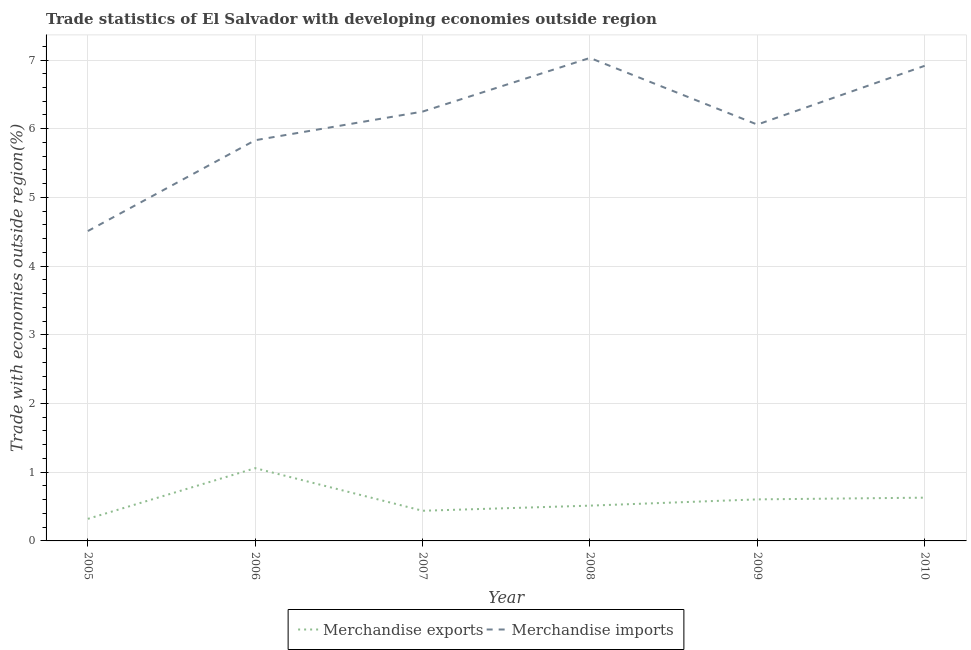Does the line corresponding to merchandise exports intersect with the line corresponding to merchandise imports?
Offer a terse response. No. Is the number of lines equal to the number of legend labels?
Keep it short and to the point. Yes. What is the merchandise exports in 2008?
Provide a succinct answer. 0.51. Across all years, what is the maximum merchandise exports?
Give a very brief answer. 1.06. Across all years, what is the minimum merchandise exports?
Your answer should be compact. 0.32. In which year was the merchandise imports maximum?
Your response must be concise. 2008. In which year was the merchandise imports minimum?
Your response must be concise. 2005. What is the total merchandise imports in the graph?
Make the answer very short. 36.6. What is the difference between the merchandise imports in 2008 and that in 2010?
Keep it short and to the point. 0.11. What is the difference between the merchandise imports in 2010 and the merchandise exports in 2008?
Provide a short and direct response. 6.4. What is the average merchandise imports per year?
Offer a very short reply. 6.1. In the year 2010, what is the difference between the merchandise imports and merchandise exports?
Provide a succinct answer. 6.29. In how many years, is the merchandise imports greater than 1.2 %?
Your answer should be compact. 6. What is the ratio of the merchandise imports in 2007 to that in 2008?
Keep it short and to the point. 0.89. What is the difference between the highest and the second highest merchandise imports?
Your response must be concise. 0.11. What is the difference between the highest and the lowest merchandise exports?
Your response must be concise. 0.74. Is the sum of the merchandise exports in 2005 and 2010 greater than the maximum merchandise imports across all years?
Provide a short and direct response. No. Is the merchandise exports strictly greater than the merchandise imports over the years?
Provide a succinct answer. No. Is the merchandise exports strictly less than the merchandise imports over the years?
Your answer should be compact. Yes. How many lines are there?
Make the answer very short. 2. How many years are there in the graph?
Provide a short and direct response. 6. Are the values on the major ticks of Y-axis written in scientific E-notation?
Offer a terse response. No. How many legend labels are there?
Offer a very short reply. 2. What is the title of the graph?
Your response must be concise. Trade statistics of El Salvador with developing economies outside region. Does "Urban agglomerations" appear as one of the legend labels in the graph?
Keep it short and to the point. No. What is the label or title of the X-axis?
Give a very brief answer. Year. What is the label or title of the Y-axis?
Provide a short and direct response. Trade with economies outside region(%). What is the Trade with economies outside region(%) in Merchandise exports in 2005?
Ensure brevity in your answer.  0.32. What is the Trade with economies outside region(%) in Merchandise imports in 2005?
Offer a terse response. 4.51. What is the Trade with economies outside region(%) of Merchandise exports in 2006?
Offer a very short reply. 1.06. What is the Trade with economies outside region(%) of Merchandise imports in 2006?
Provide a succinct answer. 5.83. What is the Trade with economies outside region(%) in Merchandise exports in 2007?
Provide a succinct answer. 0.44. What is the Trade with economies outside region(%) in Merchandise imports in 2007?
Ensure brevity in your answer.  6.25. What is the Trade with economies outside region(%) of Merchandise exports in 2008?
Give a very brief answer. 0.51. What is the Trade with economies outside region(%) in Merchandise imports in 2008?
Your response must be concise. 7.03. What is the Trade with economies outside region(%) of Merchandise exports in 2009?
Keep it short and to the point. 0.6. What is the Trade with economies outside region(%) of Merchandise imports in 2009?
Offer a terse response. 6.06. What is the Trade with economies outside region(%) in Merchandise exports in 2010?
Offer a very short reply. 0.63. What is the Trade with economies outside region(%) in Merchandise imports in 2010?
Your answer should be very brief. 6.92. Across all years, what is the maximum Trade with economies outside region(%) of Merchandise exports?
Offer a very short reply. 1.06. Across all years, what is the maximum Trade with economies outside region(%) in Merchandise imports?
Provide a short and direct response. 7.03. Across all years, what is the minimum Trade with economies outside region(%) in Merchandise exports?
Your answer should be compact. 0.32. Across all years, what is the minimum Trade with economies outside region(%) of Merchandise imports?
Your answer should be compact. 4.51. What is the total Trade with economies outside region(%) in Merchandise exports in the graph?
Offer a terse response. 3.57. What is the total Trade with economies outside region(%) in Merchandise imports in the graph?
Your response must be concise. 36.6. What is the difference between the Trade with economies outside region(%) of Merchandise exports in 2005 and that in 2006?
Keep it short and to the point. -0.74. What is the difference between the Trade with economies outside region(%) in Merchandise imports in 2005 and that in 2006?
Your response must be concise. -1.32. What is the difference between the Trade with economies outside region(%) in Merchandise exports in 2005 and that in 2007?
Provide a short and direct response. -0.12. What is the difference between the Trade with economies outside region(%) in Merchandise imports in 2005 and that in 2007?
Make the answer very short. -1.74. What is the difference between the Trade with economies outside region(%) in Merchandise exports in 2005 and that in 2008?
Provide a succinct answer. -0.19. What is the difference between the Trade with economies outside region(%) of Merchandise imports in 2005 and that in 2008?
Your answer should be compact. -2.52. What is the difference between the Trade with economies outside region(%) of Merchandise exports in 2005 and that in 2009?
Your answer should be very brief. -0.28. What is the difference between the Trade with economies outside region(%) in Merchandise imports in 2005 and that in 2009?
Make the answer very short. -1.55. What is the difference between the Trade with economies outside region(%) of Merchandise exports in 2005 and that in 2010?
Give a very brief answer. -0.31. What is the difference between the Trade with economies outside region(%) in Merchandise imports in 2005 and that in 2010?
Make the answer very short. -2.4. What is the difference between the Trade with economies outside region(%) in Merchandise exports in 2006 and that in 2007?
Provide a succinct answer. 0.62. What is the difference between the Trade with economies outside region(%) of Merchandise imports in 2006 and that in 2007?
Provide a short and direct response. -0.42. What is the difference between the Trade with economies outside region(%) of Merchandise exports in 2006 and that in 2008?
Your answer should be very brief. 0.55. What is the difference between the Trade with economies outside region(%) of Merchandise imports in 2006 and that in 2008?
Make the answer very short. -1.2. What is the difference between the Trade with economies outside region(%) of Merchandise exports in 2006 and that in 2009?
Ensure brevity in your answer.  0.45. What is the difference between the Trade with economies outside region(%) in Merchandise imports in 2006 and that in 2009?
Provide a short and direct response. -0.23. What is the difference between the Trade with economies outside region(%) of Merchandise exports in 2006 and that in 2010?
Your response must be concise. 0.43. What is the difference between the Trade with economies outside region(%) of Merchandise imports in 2006 and that in 2010?
Provide a succinct answer. -1.08. What is the difference between the Trade with economies outside region(%) of Merchandise exports in 2007 and that in 2008?
Give a very brief answer. -0.07. What is the difference between the Trade with economies outside region(%) of Merchandise imports in 2007 and that in 2008?
Give a very brief answer. -0.78. What is the difference between the Trade with economies outside region(%) of Merchandise exports in 2007 and that in 2009?
Your answer should be compact. -0.17. What is the difference between the Trade with economies outside region(%) in Merchandise imports in 2007 and that in 2009?
Ensure brevity in your answer.  0.19. What is the difference between the Trade with economies outside region(%) of Merchandise exports in 2007 and that in 2010?
Offer a very short reply. -0.19. What is the difference between the Trade with economies outside region(%) of Merchandise imports in 2007 and that in 2010?
Provide a succinct answer. -0.67. What is the difference between the Trade with economies outside region(%) of Merchandise exports in 2008 and that in 2009?
Your answer should be very brief. -0.09. What is the difference between the Trade with economies outside region(%) in Merchandise imports in 2008 and that in 2009?
Offer a very short reply. 0.97. What is the difference between the Trade with economies outside region(%) of Merchandise exports in 2008 and that in 2010?
Make the answer very short. -0.12. What is the difference between the Trade with economies outside region(%) in Merchandise imports in 2008 and that in 2010?
Offer a very short reply. 0.11. What is the difference between the Trade with economies outside region(%) of Merchandise exports in 2009 and that in 2010?
Make the answer very short. -0.03. What is the difference between the Trade with economies outside region(%) in Merchandise imports in 2009 and that in 2010?
Give a very brief answer. -0.86. What is the difference between the Trade with economies outside region(%) of Merchandise exports in 2005 and the Trade with economies outside region(%) of Merchandise imports in 2006?
Your answer should be compact. -5.51. What is the difference between the Trade with economies outside region(%) of Merchandise exports in 2005 and the Trade with economies outside region(%) of Merchandise imports in 2007?
Your answer should be very brief. -5.93. What is the difference between the Trade with economies outside region(%) in Merchandise exports in 2005 and the Trade with economies outside region(%) in Merchandise imports in 2008?
Offer a very short reply. -6.71. What is the difference between the Trade with economies outside region(%) in Merchandise exports in 2005 and the Trade with economies outside region(%) in Merchandise imports in 2009?
Offer a terse response. -5.74. What is the difference between the Trade with economies outside region(%) in Merchandise exports in 2005 and the Trade with economies outside region(%) in Merchandise imports in 2010?
Offer a terse response. -6.59. What is the difference between the Trade with economies outside region(%) of Merchandise exports in 2006 and the Trade with economies outside region(%) of Merchandise imports in 2007?
Offer a very short reply. -5.19. What is the difference between the Trade with economies outside region(%) in Merchandise exports in 2006 and the Trade with economies outside region(%) in Merchandise imports in 2008?
Ensure brevity in your answer.  -5.97. What is the difference between the Trade with economies outside region(%) of Merchandise exports in 2006 and the Trade with economies outside region(%) of Merchandise imports in 2009?
Offer a terse response. -5. What is the difference between the Trade with economies outside region(%) of Merchandise exports in 2006 and the Trade with economies outside region(%) of Merchandise imports in 2010?
Ensure brevity in your answer.  -5.86. What is the difference between the Trade with economies outside region(%) in Merchandise exports in 2007 and the Trade with economies outside region(%) in Merchandise imports in 2008?
Your response must be concise. -6.59. What is the difference between the Trade with economies outside region(%) in Merchandise exports in 2007 and the Trade with economies outside region(%) in Merchandise imports in 2009?
Your answer should be compact. -5.62. What is the difference between the Trade with economies outside region(%) in Merchandise exports in 2007 and the Trade with economies outside region(%) in Merchandise imports in 2010?
Make the answer very short. -6.48. What is the difference between the Trade with economies outside region(%) in Merchandise exports in 2008 and the Trade with economies outside region(%) in Merchandise imports in 2009?
Provide a short and direct response. -5.55. What is the difference between the Trade with economies outside region(%) in Merchandise exports in 2008 and the Trade with economies outside region(%) in Merchandise imports in 2010?
Offer a very short reply. -6.4. What is the difference between the Trade with economies outside region(%) in Merchandise exports in 2009 and the Trade with economies outside region(%) in Merchandise imports in 2010?
Provide a succinct answer. -6.31. What is the average Trade with economies outside region(%) in Merchandise exports per year?
Provide a succinct answer. 0.59. What is the average Trade with economies outside region(%) of Merchandise imports per year?
Provide a succinct answer. 6.1. In the year 2005, what is the difference between the Trade with economies outside region(%) of Merchandise exports and Trade with economies outside region(%) of Merchandise imports?
Your response must be concise. -4.19. In the year 2006, what is the difference between the Trade with economies outside region(%) in Merchandise exports and Trade with economies outside region(%) in Merchandise imports?
Provide a short and direct response. -4.77. In the year 2007, what is the difference between the Trade with economies outside region(%) in Merchandise exports and Trade with economies outside region(%) in Merchandise imports?
Your answer should be very brief. -5.81. In the year 2008, what is the difference between the Trade with economies outside region(%) of Merchandise exports and Trade with economies outside region(%) of Merchandise imports?
Make the answer very short. -6.52. In the year 2009, what is the difference between the Trade with economies outside region(%) of Merchandise exports and Trade with economies outside region(%) of Merchandise imports?
Your answer should be compact. -5.46. In the year 2010, what is the difference between the Trade with economies outside region(%) of Merchandise exports and Trade with economies outside region(%) of Merchandise imports?
Your answer should be very brief. -6.29. What is the ratio of the Trade with economies outside region(%) of Merchandise exports in 2005 to that in 2006?
Ensure brevity in your answer.  0.3. What is the ratio of the Trade with economies outside region(%) in Merchandise imports in 2005 to that in 2006?
Keep it short and to the point. 0.77. What is the ratio of the Trade with economies outside region(%) of Merchandise exports in 2005 to that in 2007?
Provide a short and direct response. 0.73. What is the ratio of the Trade with economies outside region(%) of Merchandise imports in 2005 to that in 2007?
Keep it short and to the point. 0.72. What is the ratio of the Trade with economies outside region(%) of Merchandise exports in 2005 to that in 2008?
Provide a succinct answer. 0.63. What is the ratio of the Trade with economies outside region(%) of Merchandise imports in 2005 to that in 2008?
Your answer should be compact. 0.64. What is the ratio of the Trade with economies outside region(%) in Merchandise exports in 2005 to that in 2009?
Keep it short and to the point. 0.53. What is the ratio of the Trade with economies outside region(%) of Merchandise imports in 2005 to that in 2009?
Offer a very short reply. 0.74. What is the ratio of the Trade with economies outside region(%) in Merchandise exports in 2005 to that in 2010?
Keep it short and to the point. 0.51. What is the ratio of the Trade with economies outside region(%) of Merchandise imports in 2005 to that in 2010?
Provide a succinct answer. 0.65. What is the ratio of the Trade with economies outside region(%) of Merchandise exports in 2006 to that in 2007?
Your answer should be very brief. 2.41. What is the ratio of the Trade with economies outside region(%) in Merchandise exports in 2006 to that in 2008?
Provide a short and direct response. 2.06. What is the ratio of the Trade with economies outside region(%) in Merchandise imports in 2006 to that in 2008?
Offer a terse response. 0.83. What is the ratio of the Trade with economies outside region(%) in Merchandise exports in 2006 to that in 2009?
Ensure brevity in your answer.  1.75. What is the ratio of the Trade with economies outside region(%) in Merchandise imports in 2006 to that in 2009?
Your answer should be very brief. 0.96. What is the ratio of the Trade with economies outside region(%) of Merchandise exports in 2006 to that in 2010?
Offer a terse response. 1.68. What is the ratio of the Trade with economies outside region(%) of Merchandise imports in 2006 to that in 2010?
Make the answer very short. 0.84. What is the ratio of the Trade with economies outside region(%) in Merchandise exports in 2007 to that in 2008?
Provide a short and direct response. 0.85. What is the ratio of the Trade with economies outside region(%) in Merchandise exports in 2007 to that in 2009?
Offer a very short reply. 0.73. What is the ratio of the Trade with economies outside region(%) in Merchandise imports in 2007 to that in 2009?
Your answer should be compact. 1.03. What is the ratio of the Trade with economies outside region(%) of Merchandise exports in 2007 to that in 2010?
Keep it short and to the point. 0.7. What is the ratio of the Trade with economies outside region(%) of Merchandise imports in 2007 to that in 2010?
Your response must be concise. 0.9. What is the ratio of the Trade with economies outside region(%) in Merchandise exports in 2008 to that in 2009?
Provide a succinct answer. 0.85. What is the ratio of the Trade with economies outside region(%) in Merchandise imports in 2008 to that in 2009?
Provide a short and direct response. 1.16. What is the ratio of the Trade with economies outside region(%) of Merchandise exports in 2008 to that in 2010?
Offer a very short reply. 0.82. What is the ratio of the Trade with economies outside region(%) in Merchandise imports in 2008 to that in 2010?
Offer a very short reply. 1.02. What is the ratio of the Trade with economies outside region(%) of Merchandise exports in 2009 to that in 2010?
Give a very brief answer. 0.96. What is the ratio of the Trade with economies outside region(%) of Merchandise imports in 2009 to that in 2010?
Give a very brief answer. 0.88. What is the difference between the highest and the second highest Trade with economies outside region(%) of Merchandise exports?
Your answer should be very brief. 0.43. What is the difference between the highest and the second highest Trade with economies outside region(%) in Merchandise imports?
Keep it short and to the point. 0.11. What is the difference between the highest and the lowest Trade with economies outside region(%) of Merchandise exports?
Offer a very short reply. 0.74. What is the difference between the highest and the lowest Trade with economies outside region(%) of Merchandise imports?
Make the answer very short. 2.52. 